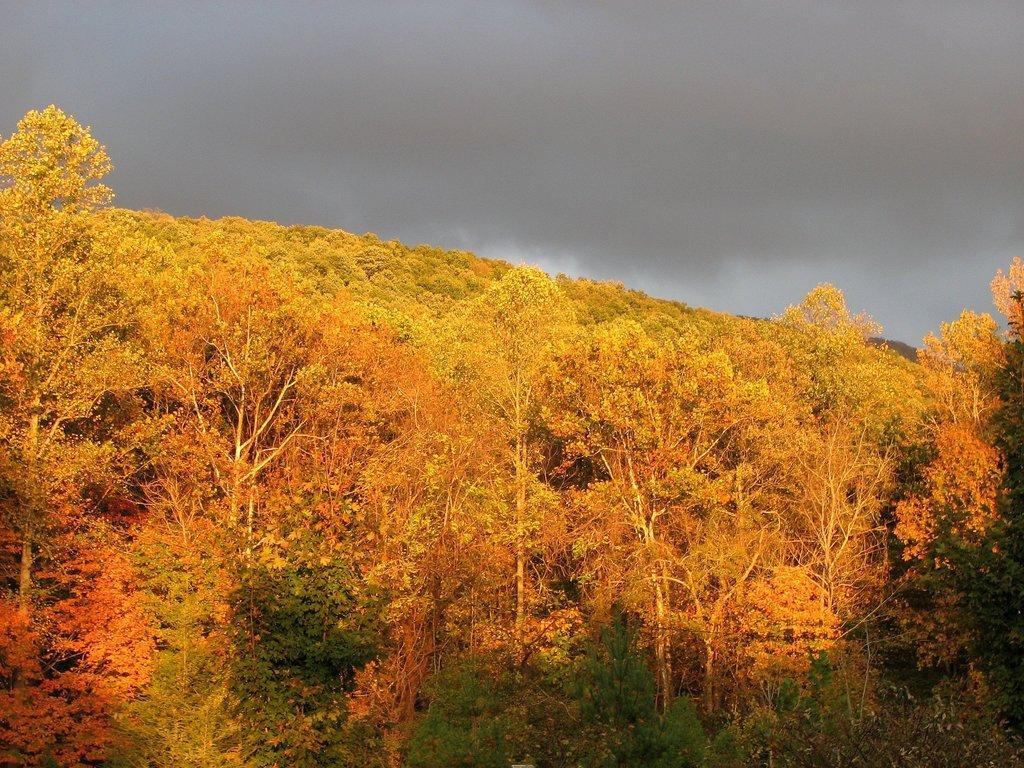Please provide a concise description of this image. In this picture we can see few trees and clouds. 